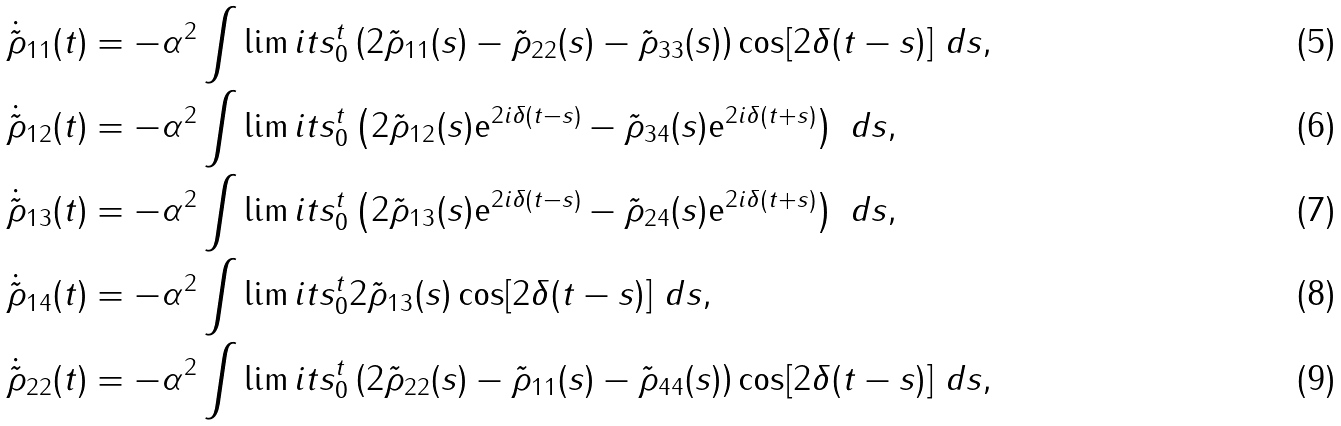<formula> <loc_0><loc_0><loc_500><loc_500>\dot { \tilde { \rho } } _ { 1 1 } ( t ) & = - \alpha ^ { 2 } \int \lim i t s _ { 0 } ^ { t } \left ( 2 \tilde { \rho } _ { 1 1 } ( s ) - \tilde { \rho } _ { 2 2 } ( s ) - \tilde { \rho } _ { 3 3 } ( s ) \right ) \cos [ 2 \delta ( t - s ) ] \ d s , \\ \dot { \tilde { \rho } } _ { 1 2 } ( t ) & = - \alpha ^ { 2 } \int \lim i t s _ { 0 } ^ { t } \left ( 2 \tilde { \rho } _ { 1 2 } ( s ) \mathrm e ^ { 2 i \delta ( t - s ) } - \tilde { \rho } _ { 3 4 } ( s ) \mathrm e ^ { 2 i \delta ( t + s ) } \right ) \ d s , \\ \dot { \tilde { \rho } } _ { 1 3 } ( t ) & = - \alpha ^ { 2 } \int \lim i t s _ { 0 } ^ { t } \left ( 2 \tilde { \rho } _ { 1 3 } ( s ) \mathrm e ^ { 2 i \delta ( t - s ) } - \tilde { \rho } _ { 2 4 } ( s ) \mathrm e ^ { 2 i \delta ( t + s ) } \right ) \ d s , \\ \dot { \tilde { \rho } } _ { 1 4 } ( t ) & = - \alpha ^ { 2 } \int \lim i t s _ { 0 } ^ { t } 2 \tilde { \rho } _ { 1 3 } ( s ) \cos [ 2 \delta ( t - s ) ] \ d s , \\ \dot { \tilde { \rho } } _ { 2 2 } ( t ) & = - \alpha ^ { 2 } \int \lim i t s _ { 0 } ^ { t } \left ( 2 \tilde { \rho } _ { 2 2 } ( s ) - \tilde { \rho } _ { 1 1 } ( s ) - \tilde { \rho } _ { 4 4 } ( s ) \right ) \cos [ 2 \delta ( t - s ) ] \ d s ,</formula> 